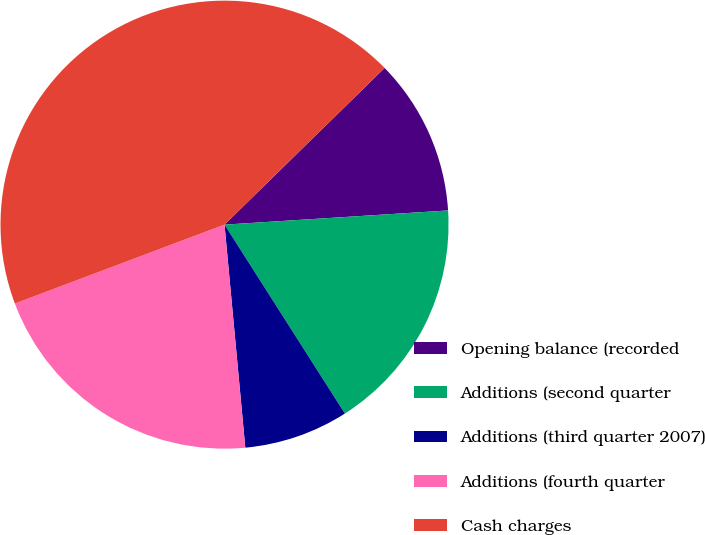<chart> <loc_0><loc_0><loc_500><loc_500><pie_chart><fcel>Opening balance (recorded<fcel>Additions (second quarter<fcel>Additions (third quarter 2007)<fcel>Additions (fourth quarter<fcel>Cash charges<nl><fcel>11.32%<fcel>16.98%<fcel>7.55%<fcel>20.75%<fcel>43.4%<nl></chart> 